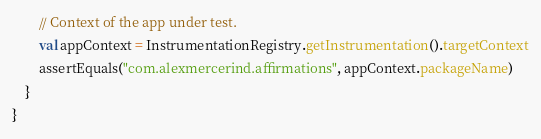<code> <loc_0><loc_0><loc_500><loc_500><_Kotlin_>        // Context of the app under test.
        val appContext = InstrumentationRegistry.getInstrumentation().targetContext
        assertEquals("com.alexmercerind.affirmations", appContext.packageName)
    }
}</code> 